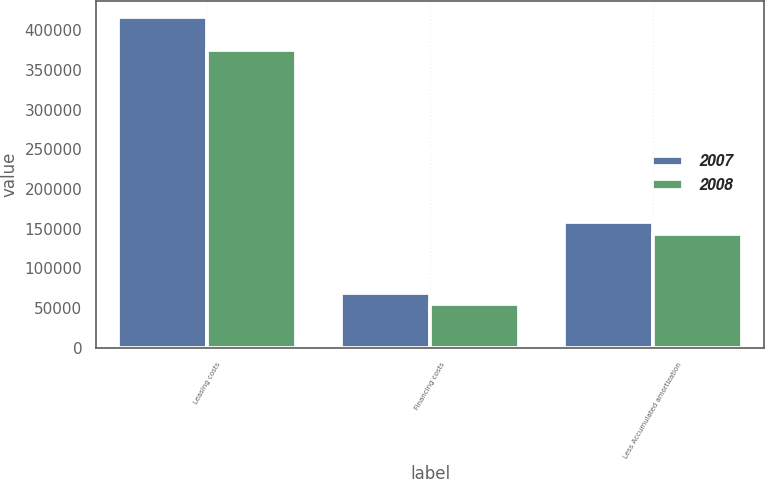<chart> <loc_0><loc_0><loc_500><loc_500><stacked_bar_chart><ecel><fcel>Leasing costs<fcel>Financing costs<fcel>Less Accumulated amortization<nl><fcel>2007<fcel>416299<fcel>68626<fcel>158524<nl><fcel>2008<fcel>375004<fcel>55580<fcel>143385<nl></chart> 